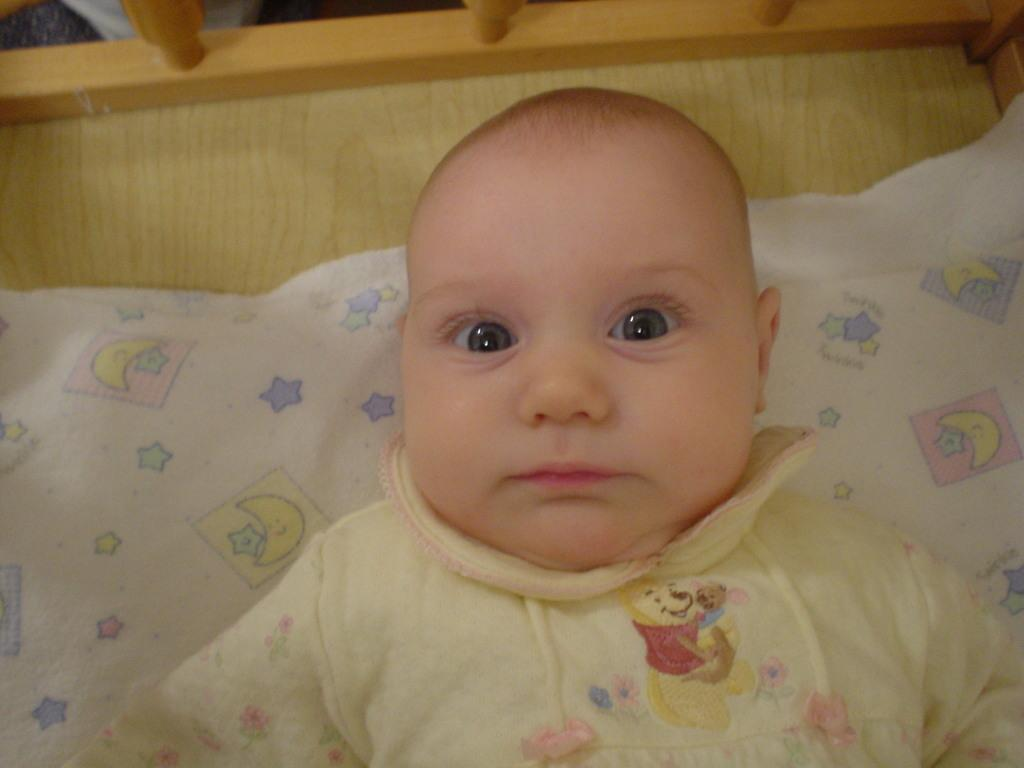What is the main subject of the image? There is a baby in the image. What is the baby wearing? The baby is wearing a yellow dress. What is the baby doing in the image? The baby is sleeping. Can you describe any other objects in the image? There is a white color object in the image. What type of crayon is the baby using to write in the image? There is no crayon or writing present in the image; the baby is sleeping. 